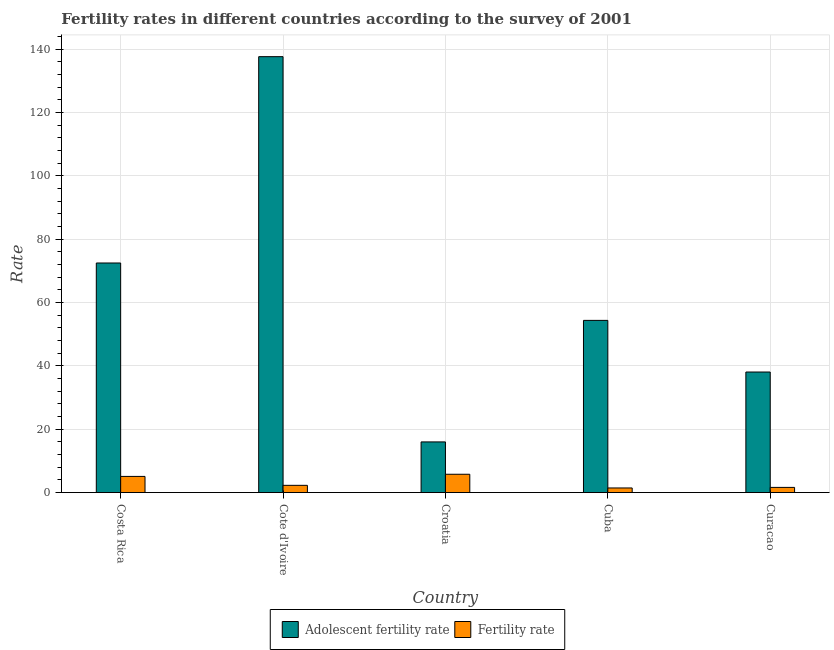How many different coloured bars are there?
Your answer should be very brief. 2. How many groups of bars are there?
Provide a short and direct response. 5. Are the number of bars per tick equal to the number of legend labels?
Give a very brief answer. Yes. Are the number of bars on each tick of the X-axis equal?
Provide a short and direct response. Yes. How many bars are there on the 3rd tick from the right?
Give a very brief answer. 2. What is the label of the 2nd group of bars from the left?
Offer a very short reply. Cote d'Ivoire. What is the fertility rate in Cote d'Ivoire?
Provide a short and direct response. 2.29. Across all countries, what is the maximum adolescent fertility rate?
Your answer should be compact. 137.58. Across all countries, what is the minimum fertility rate?
Keep it short and to the point. 1.46. In which country was the adolescent fertility rate maximum?
Make the answer very short. Cote d'Ivoire. In which country was the adolescent fertility rate minimum?
Make the answer very short. Croatia. What is the total fertility rate in the graph?
Your answer should be very brief. 16.28. What is the difference between the fertility rate in Cote d'Ivoire and that in Croatia?
Make the answer very short. -3.5. What is the difference between the adolescent fertility rate in Croatia and the fertility rate in Cote d'Ivoire?
Your answer should be very brief. 13.7. What is the average fertility rate per country?
Offer a terse response. 3.26. What is the difference between the adolescent fertility rate and fertility rate in Cote d'Ivoire?
Make the answer very short. 135.29. In how many countries, is the adolescent fertility rate greater than 36 ?
Provide a short and direct response. 4. What is the ratio of the adolescent fertility rate in Costa Rica to that in Croatia?
Your answer should be compact. 4.53. Is the fertility rate in Cuba less than that in Curacao?
Give a very brief answer. Yes. Is the difference between the fertility rate in Cote d'Ivoire and Croatia greater than the difference between the adolescent fertility rate in Cote d'Ivoire and Croatia?
Provide a short and direct response. No. What is the difference between the highest and the second highest adolescent fertility rate?
Make the answer very short. 65.12. What is the difference between the highest and the lowest adolescent fertility rate?
Make the answer very short. 121.59. Is the sum of the adolescent fertility rate in Costa Rica and Cuba greater than the maximum fertility rate across all countries?
Keep it short and to the point. Yes. What does the 1st bar from the left in Croatia represents?
Provide a succinct answer. Adolescent fertility rate. What does the 2nd bar from the right in Cote d'Ivoire represents?
Provide a short and direct response. Adolescent fertility rate. Are all the bars in the graph horizontal?
Offer a terse response. No. How many countries are there in the graph?
Offer a very short reply. 5. What is the difference between two consecutive major ticks on the Y-axis?
Give a very brief answer. 20. How are the legend labels stacked?
Your response must be concise. Horizontal. What is the title of the graph?
Offer a very short reply. Fertility rates in different countries according to the survey of 2001. Does "Merchandise imports" appear as one of the legend labels in the graph?
Provide a succinct answer. No. What is the label or title of the Y-axis?
Provide a short and direct response. Rate. What is the Rate of Adolescent fertility rate in Costa Rica?
Your answer should be compact. 72.47. What is the Rate of Fertility rate in Costa Rica?
Give a very brief answer. 5.11. What is the Rate in Adolescent fertility rate in Cote d'Ivoire?
Offer a terse response. 137.58. What is the Rate in Fertility rate in Cote d'Ivoire?
Your answer should be very brief. 2.29. What is the Rate of Adolescent fertility rate in Croatia?
Make the answer very short. 15.99. What is the Rate of Fertility rate in Croatia?
Provide a short and direct response. 5.79. What is the Rate in Adolescent fertility rate in Cuba?
Offer a very short reply. 54.35. What is the Rate in Fertility rate in Cuba?
Keep it short and to the point. 1.46. What is the Rate of Adolescent fertility rate in Curacao?
Give a very brief answer. 38.05. What is the Rate of Fertility rate in Curacao?
Make the answer very short. 1.64. Across all countries, what is the maximum Rate of Adolescent fertility rate?
Your answer should be very brief. 137.58. Across all countries, what is the maximum Rate of Fertility rate?
Ensure brevity in your answer.  5.79. Across all countries, what is the minimum Rate in Adolescent fertility rate?
Ensure brevity in your answer.  15.99. Across all countries, what is the minimum Rate of Fertility rate?
Your response must be concise. 1.46. What is the total Rate in Adolescent fertility rate in the graph?
Offer a terse response. 318.45. What is the total Rate in Fertility rate in the graph?
Offer a very short reply. 16.28. What is the difference between the Rate in Adolescent fertility rate in Costa Rica and that in Cote d'Ivoire?
Offer a very short reply. -65.12. What is the difference between the Rate in Fertility rate in Costa Rica and that in Cote d'Ivoire?
Provide a short and direct response. 2.81. What is the difference between the Rate in Adolescent fertility rate in Costa Rica and that in Croatia?
Your answer should be very brief. 56.47. What is the difference between the Rate of Fertility rate in Costa Rica and that in Croatia?
Offer a terse response. -0.68. What is the difference between the Rate in Adolescent fertility rate in Costa Rica and that in Cuba?
Your answer should be very brief. 18.11. What is the difference between the Rate of Fertility rate in Costa Rica and that in Cuba?
Offer a terse response. 3.65. What is the difference between the Rate in Adolescent fertility rate in Costa Rica and that in Curacao?
Ensure brevity in your answer.  34.41. What is the difference between the Rate of Fertility rate in Costa Rica and that in Curacao?
Your answer should be compact. 3.46. What is the difference between the Rate in Adolescent fertility rate in Cote d'Ivoire and that in Croatia?
Provide a succinct answer. 121.59. What is the difference between the Rate in Fertility rate in Cote d'Ivoire and that in Croatia?
Give a very brief answer. -3.5. What is the difference between the Rate of Adolescent fertility rate in Cote d'Ivoire and that in Cuba?
Give a very brief answer. 83.23. What is the difference between the Rate of Fertility rate in Cote d'Ivoire and that in Cuba?
Your answer should be very brief. 0.83. What is the difference between the Rate in Adolescent fertility rate in Cote d'Ivoire and that in Curacao?
Give a very brief answer. 99.53. What is the difference between the Rate of Fertility rate in Cote d'Ivoire and that in Curacao?
Your answer should be compact. 0.65. What is the difference between the Rate in Adolescent fertility rate in Croatia and that in Cuba?
Your answer should be very brief. -38.36. What is the difference between the Rate in Fertility rate in Croatia and that in Cuba?
Keep it short and to the point. 4.33. What is the difference between the Rate in Adolescent fertility rate in Croatia and that in Curacao?
Offer a very short reply. -22.06. What is the difference between the Rate in Fertility rate in Croatia and that in Curacao?
Your response must be concise. 4.15. What is the difference between the Rate of Adolescent fertility rate in Cuba and that in Curacao?
Give a very brief answer. 16.3. What is the difference between the Rate in Fertility rate in Cuba and that in Curacao?
Your response must be concise. -0.18. What is the difference between the Rate of Adolescent fertility rate in Costa Rica and the Rate of Fertility rate in Cote d'Ivoire?
Make the answer very short. 70.18. What is the difference between the Rate of Adolescent fertility rate in Costa Rica and the Rate of Fertility rate in Croatia?
Provide a succinct answer. 66.68. What is the difference between the Rate of Adolescent fertility rate in Costa Rica and the Rate of Fertility rate in Cuba?
Offer a terse response. 71.01. What is the difference between the Rate in Adolescent fertility rate in Costa Rica and the Rate in Fertility rate in Curacao?
Offer a terse response. 70.83. What is the difference between the Rate of Adolescent fertility rate in Cote d'Ivoire and the Rate of Fertility rate in Croatia?
Provide a succinct answer. 131.8. What is the difference between the Rate of Adolescent fertility rate in Cote d'Ivoire and the Rate of Fertility rate in Cuba?
Provide a short and direct response. 136.12. What is the difference between the Rate in Adolescent fertility rate in Cote d'Ivoire and the Rate in Fertility rate in Curacao?
Offer a terse response. 135.94. What is the difference between the Rate of Adolescent fertility rate in Croatia and the Rate of Fertility rate in Cuba?
Your answer should be compact. 14.53. What is the difference between the Rate in Adolescent fertility rate in Croatia and the Rate in Fertility rate in Curacao?
Ensure brevity in your answer.  14.35. What is the difference between the Rate in Adolescent fertility rate in Cuba and the Rate in Fertility rate in Curacao?
Keep it short and to the point. 52.71. What is the average Rate of Adolescent fertility rate per country?
Keep it short and to the point. 63.69. What is the average Rate of Fertility rate per country?
Keep it short and to the point. 3.26. What is the difference between the Rate of Adolescent fertility rate and Rate of Fertility rate in Costa Rica?
Your answer should be very brief. 67.36. What is the difference between the Rate of Adolescent fertility rate and Rate of Fertility rate in Cote d'Ivoire?
Give a very brief answer. 135.29. What is the difference between the Rate of Adolescent fertility rate and Rate of Fertility rate in Croatia?
Your answer should be compact. 10.2. What is the difference between the Rate of Adolescent fertility rate and Rate of Fertility rate in Cuba?
Keep it short and to the point. 52.89. What is the difference between the Rate in Adolescent fertility rate and Rate in Fertility rate in Curacao?
Provide a succinct answer. 36.41. What is the ratio of the Rate of Adolescent fertility rate in Costa Rica to that in Cote d'Ivoire?
Offer a terse response. 0.53. What is the ratio of the Rate in Fertility rate in Costa Rica to that in Cote d'Ivoire?
Provide a succinct answer. 2.23. What is the ratio of the Rate in Adolescent fertility rate in Costa Rica to that in Croatia?
Offer a terse response. 4.53. What is the ratio of the Rate in Fertility rate in Costa Rica to that in Croatia?
Make the answer very short. 0.88. What is the ratio of the Rate in Adolescent fertility rate in Costa Rica to that in Cuba?
Your answer should be very brief. 1.33. What is the ratio of the Rate of Fertility rate in Costa Rica to that in Cuba?
Offer a terse response. 3.5. What is the ratio of the Rate of Adolescent fertility rate in Costa Rica to that in Curacao?
Provide a succinct answer. 1.9. What is the ratio of the Rate in Fertility rate in Costa Rica to that in Curacao?
Give a very brief answer. 3.11. What is the ratio of the Rate of Adolescent fertility rate in Cote d'Ivoire to that in Croatia?
Keep it short and to the point. 8.6. What is the ratio of the Rate in Fertility rate in Cote d'Ivoire to that in Croatia?
Ensure brevity in your answer.  0.4. What is the ratio of the Rate of Adolescent fertility rate in Cote d'Ivoire to that in Cuba?
Your response must be concise. 2.53. What is the ratio of the Rate in Fertility rate in Cote d'Ivoire to that in Cuba?
Provide a short and direct response. 1.57. What is the ratio of the Rate of Adolescent fertility rate in Cote d'Ivoire to that in Curacao?
Make the answer very short. 3.62. What is the ratio of the Rate in Fertility rate in Cote d'Ivoire to that in Curacao?
Your answer should be compact. 1.4. What is the ratio of the Rate of Adolescent fertility rate in Croatia to that in Cuba?
Provide a succinct answer. 0.29. What is the ratio of the Rate of Fertility rate in Croatia to that in Cuba?
Give a very brief answer. 3.96. What is the ratio of the Rate of Adolescent fertility rate in Croatia to that in Curacao?
Give a very brief answer. 0.42. What is the ratio of the Rate of Fertility rate in Croatia to that in Curacao?
Ensure brevity in your answer.  3.53. What is the ratio of the Rate in Adolescent fertility rate in Cuba to that in Curacao?
Offer a very short reply. 1.43. What is the ratio of the Rate in Fertility rate in Cuba to that in Curacao?
Provide a succinct answer. 0.89. What is the difference between the highest and the second highest Rate in Adolescent fertility rate?
Ensure brevity in your answer.  65.12. What is the difference between the highest and the second highest Rate in Fertility rate?
Offer a terse response. 0.68. What is the difference between the highest and the lowest Rate of Adolescent fertility rate?
Keep it short and to the point. 121.59. What is the difference between the highest and the lowest Rate of Fertility rate?
Offer a terse response. 4.33. 